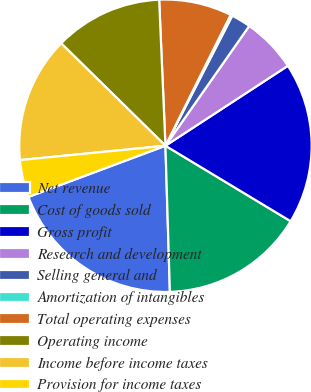<chart> <loc_0><loc_0><loc_500><loc_500><pie_chart><fcel>Net revenue<fcel>Cost of goods sold<fcel>Gross profit<fcel>Research and development<fcel>Selling general and<fcel>Amortization of intangibles<fcel>Total operating expenses<fcel>Operating income<fcel>Income before income taxes<fcel>Provision for income taxes<nl><fcel>19.8%<fcel>15.88%<fcel>17.84%<fcel>6.08%<fcel>2.16%<fcel>0.2%<fcel>8.04%<fcel>11.96%<fcel>13.92%<fcel>4.12%<nl></chart> 